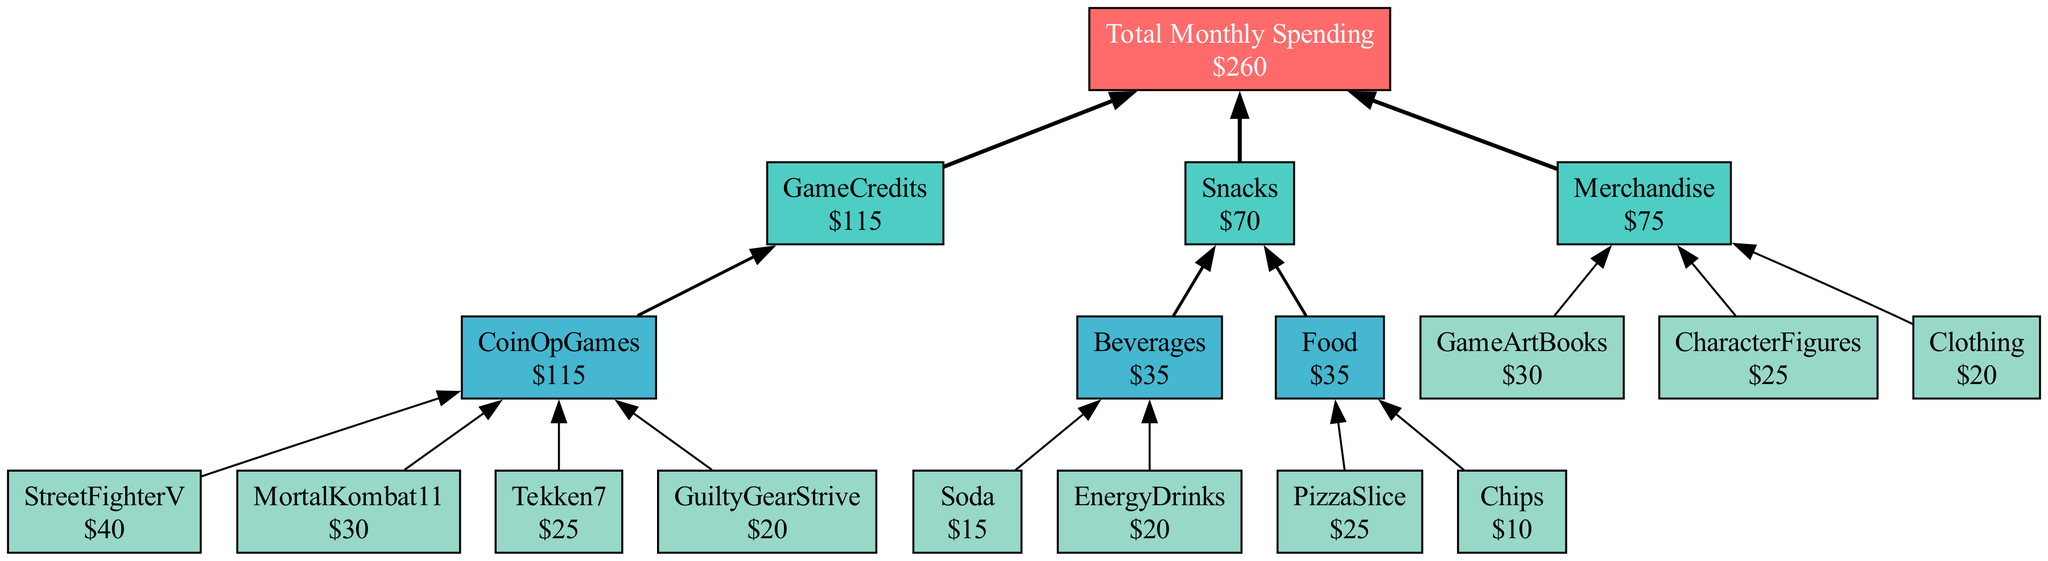What is the total monthly spending? The total monthly spending is indicated at the top of the diagram as the overarching node. It reads "Total Monthly Spending" with the value beneath it as $260.
Answer: $260 How much was spent on game credits? The node labeled "GameCredits" shows the total amount spent on game credits as $115, which is derived from the individual game credits listed below it.
Answer: $115 What is the total amount spent on snacks? The node labeled "TotalSnacks" delineates the total spending in the snacks category as $70. This total is derived from the individual snack items listed under "Snacks".
Answer: $70 Which game had the highest credit spending? Among the games listed under "CoinOpGames," "StreetFighterV" has the highest amount with $40 spent on game credits, making it the highest.
Answer: StreetFighterV How many individual items are considered in the snacks category? Under the "Snacks" category, there are two subcategories: "Beverages" (with 2 items) and "Food" (with 2 items). Thus, there are 4 distinct items total within snacks.
Answer: 4 What is the total spending on merchandise? The node labeled "TotalMerchandise" indicates that the total spending on merchandise is $75, which is calculated from the individual merchandise items listed under the "Merchandise" category.
Answer: $75 How many categories are represented in this diagram? The diagram comprises three main categories: "GameCredits," "Snacks," and "Merchandise." Therefore, there are a total of three categories represented.
Answer: 3 Which category has the highest individual item expenditure? Examining the individual item expenditures, "GameCredits" has the highest single item expenditure from "StreetFighterV" with $40.
Answer: GameCredits Where does the "Clothing" item fall under in the diagram? The "Clothing" item is found under the "Merchandise" category, signifying it is a subcategory of merchandise spending.
Answer: Merchandise 